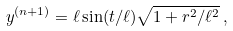Convert formula to latex. <formula><loc_0><loc_0><loc_500><loc_500>y ^ { ( n + 1 ) } = \ell \sin ( t / \ell ) \sqrt { 1 + r ^ { 2 } / \ell ^ { 2 } } \, ,</formula> 